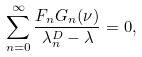Convert formula to latex. <formula><loc_0><loc_0><loc_500><loc_500>\sum _ { n = 0 } ^ { \infty } \frac { F _ { n } G _ { n } ( \nu ) } { \lambda _ { n } ^ { D } - \lambda } = 0 ,</formula> 